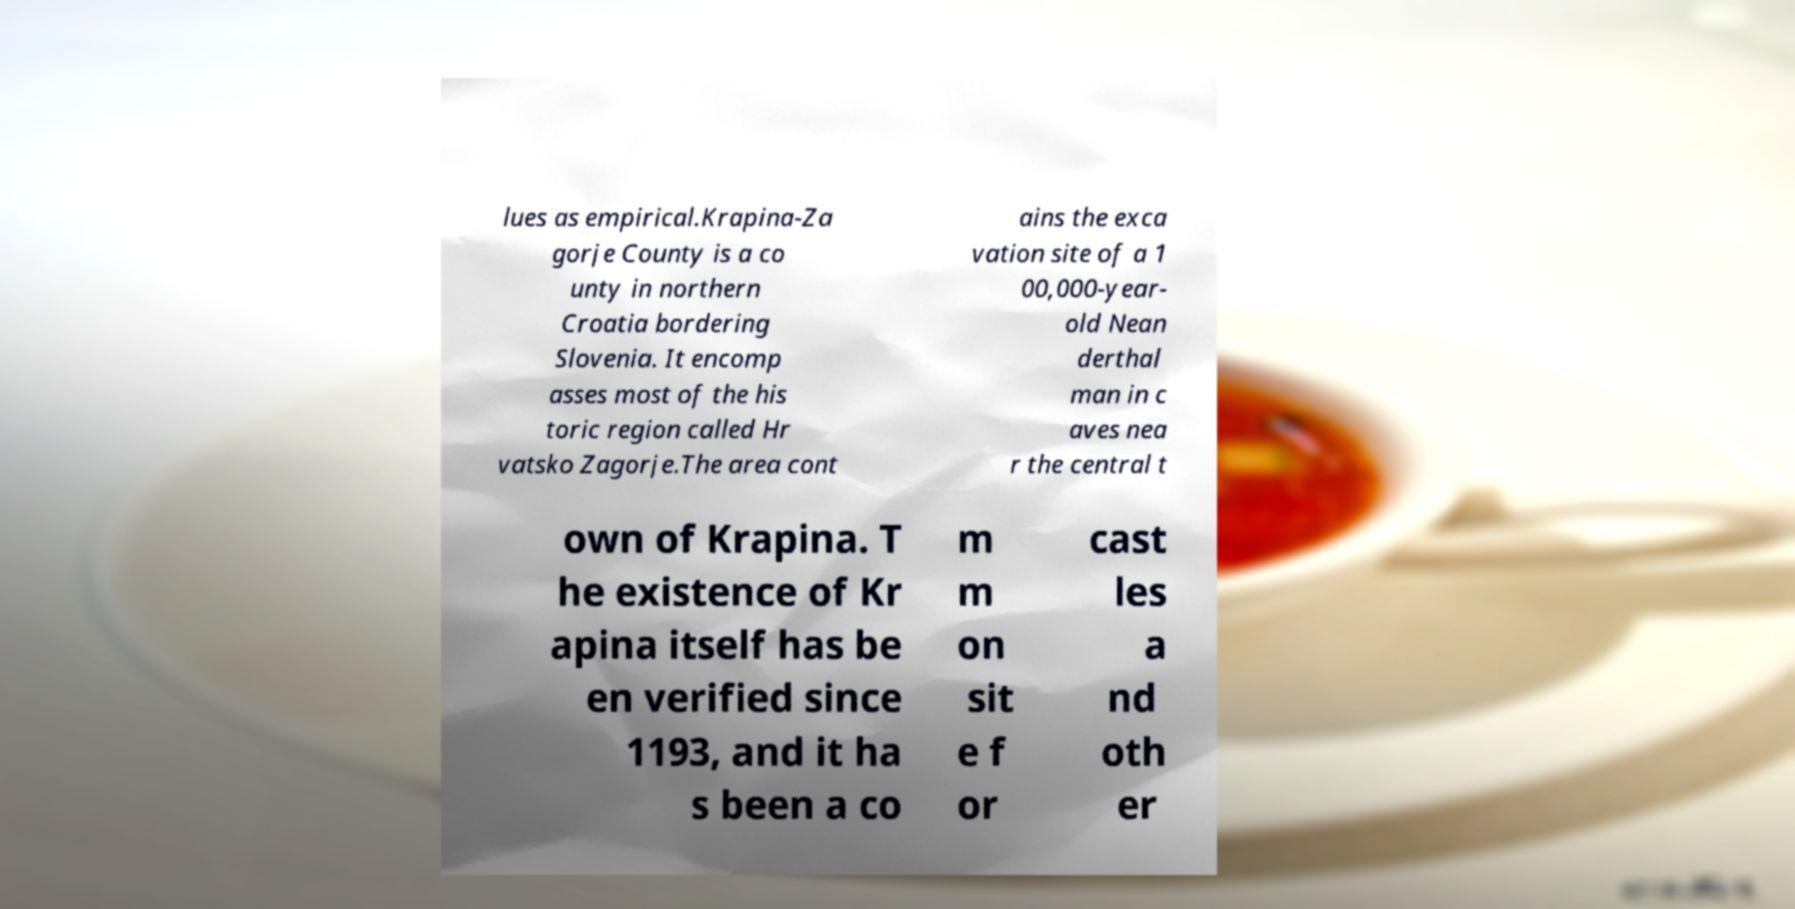What messages or text are displayed in this image? I need them in a readable, typed format. lues as empirical.Krapina-Za gorje County is a co unty in northern Croatia bordering Slovenia. It encomp asses most of the his toric region called Hr vatsko Zagorje.The area cont ains the exca vation site of a 1 00,000-year- old Nean derthal man in c aves nea r the central t own of Krapina. T he existence of Kr apina itself has be en verified since 1193, and it ha s been a co m m on sit e f or cast les a nd oth er 